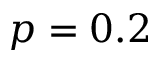<formula> <loc_0><loc_0><loc_500><loc_500>p = 0 . 2</formula> 